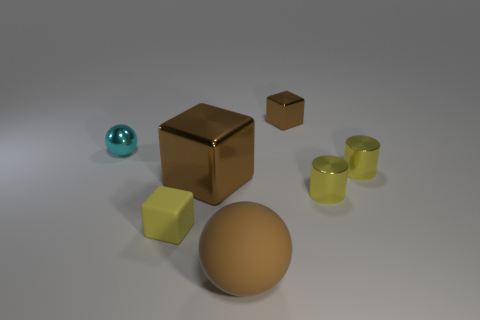Subtract all tiny yellow blocks. How many blocks are left? 2 Subtract all red spheres. How many brown blocks are left? 2 Subtract 1 cubes. How many cubes are left? 2 Subtract all purple blocks. Subtract all brown balls. How many blocks are left? 3 Add 2 rubber blocks. How many objects exist? 9 Subtract all spheres. How many objects are left? 5 Subtract all big rubber objects. Subtract all green rubber spheres. How many objects are left? 6 Add 3 cyan balls. How many cyan balls are left? 4 Add 4 brown matte things. How many brown matte things exist? 5 Subtract 1 cyan spheres. How many objects are left? 6 